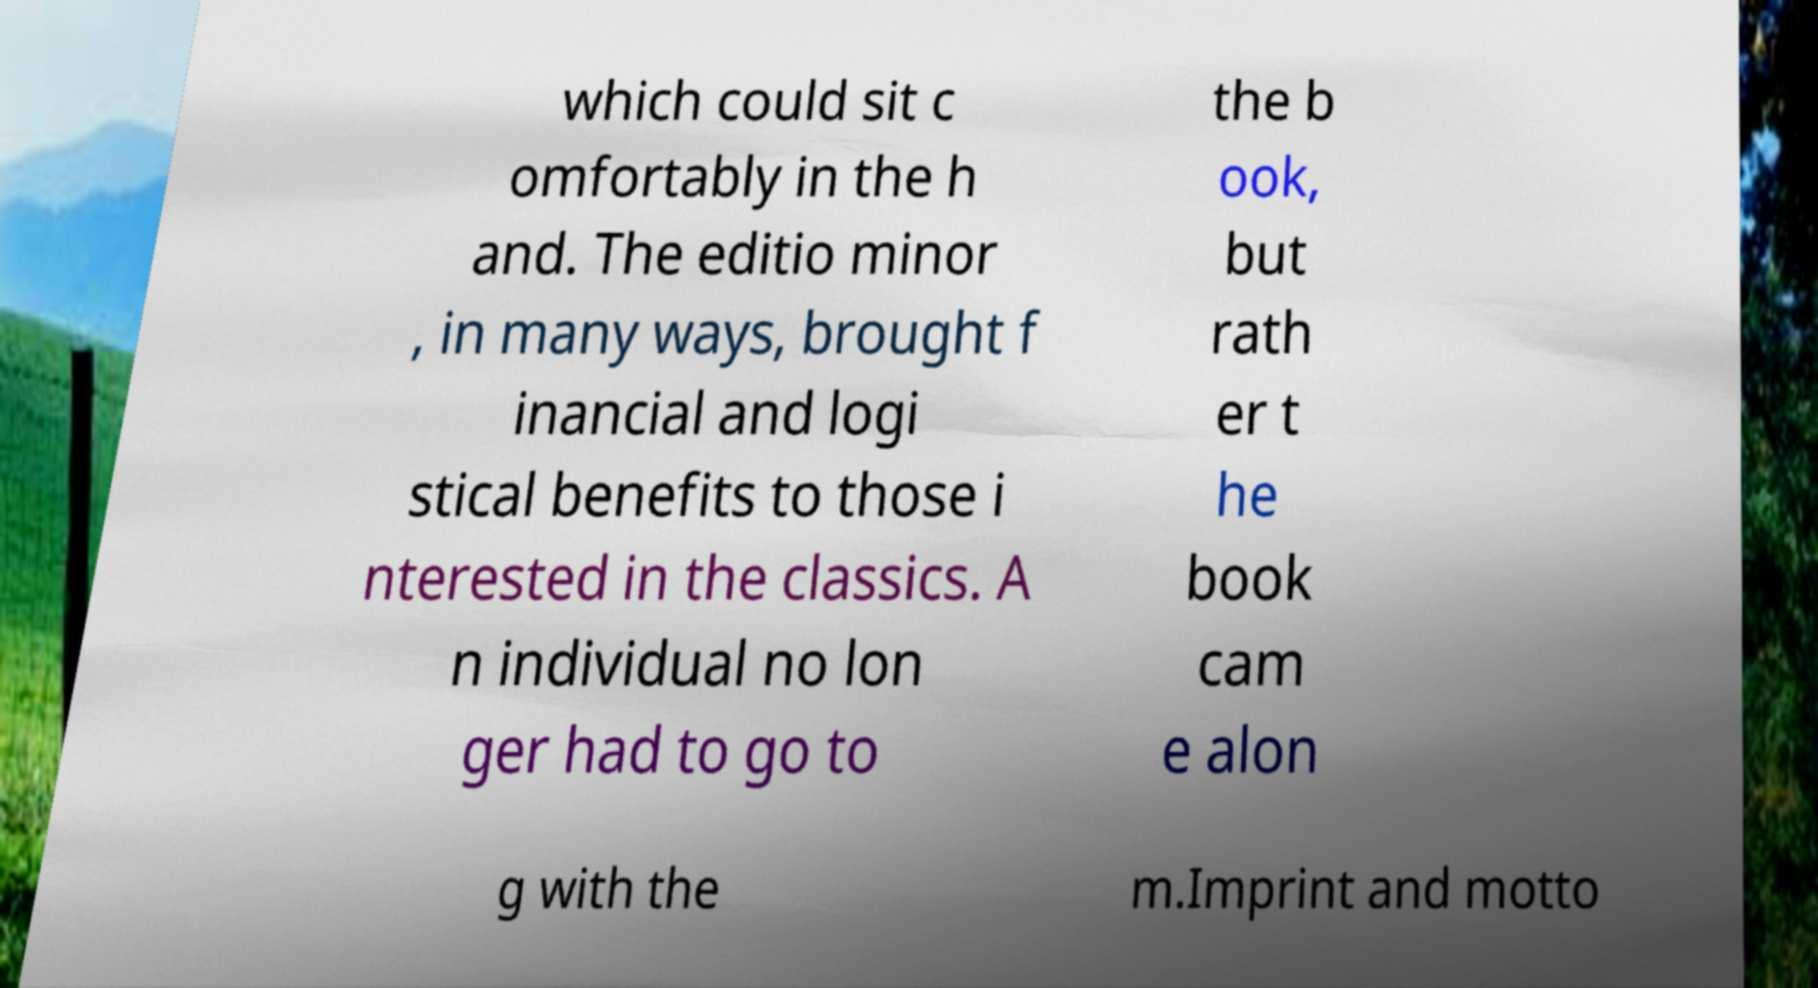For documentation purposes, I need the text within this image transcribed. Could you provide that? which could sit c omfortably in the h and. The editio minor , in many ways, brought f inancial and logi stical benefits to those i nterested in the classics. A n individual no lon ger had to go to the b ook, but rath er t he book cam e alon g with the m.Imprint and motto 